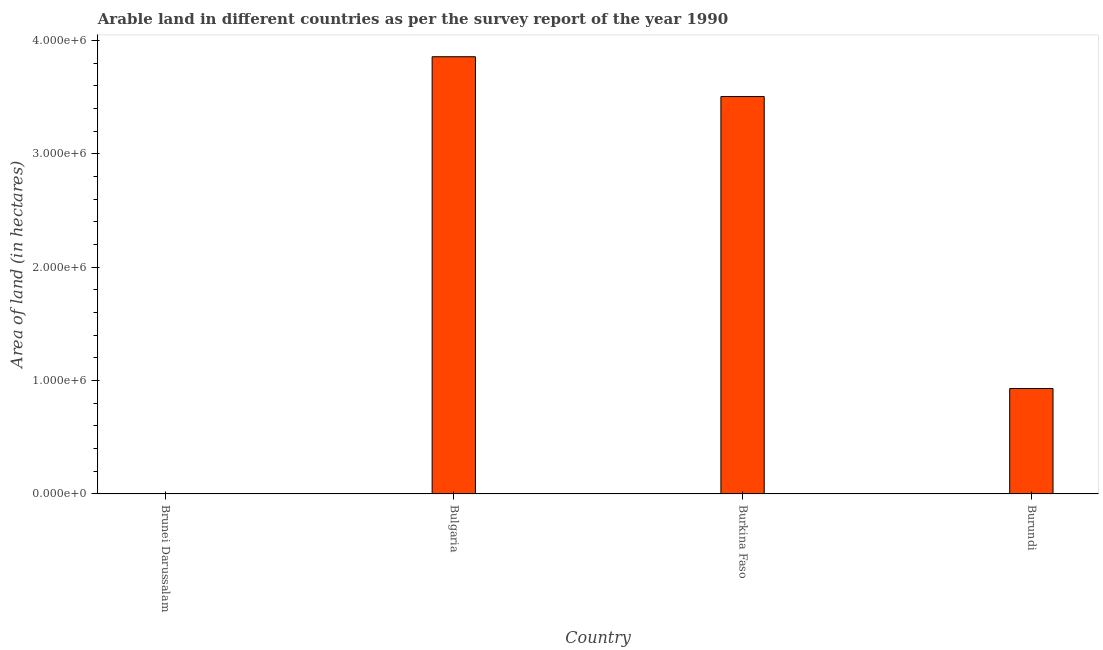Does the graph contain any zero values?
Your answer should be compact. No. What is the title of the graph?
Give a very brief answer. Arable land in different countries as per the survey report of the year 1990. What is the label or title of the Y-axis?
Provide a succinct answer. Area of land (in hectares). What is the area of land in Bulgaria?
Your answer should be very brief. 3.86e+06. Across all countries, what is the maximum area of land?
Make the answer very short. 3.86e+06. Across all countries, what is the minimum area of land?
Provide a succinct answer. 2000. In which country was the area of land maximum?
Keep it short and to the point. Bulgaria. In which country was the area of land minimum?
Give a very brief answer. Brunei Darussalam. What is the sum of the area of land?
Offer a very short reply. 8.29e+06. What is the difference between the area of land in Brunei Darussalam and Bulgaria?
Give a very brief answer. -3.85e+06. What is the average area of land per country?
Your answer should be very brief. 2.07e+06. What is the median area of land?
Make the answer very short. 2.22e+06. What is the ratio of the area of land in Bulgaria to that in Burkina Faso?
Provide a short and direct response. 1.1. Is the area of land in Bulgaria less than that in Burundi?
Offer a very short reply. No. Is the difference between the area of land in Brunei Darussalam and Bulgaria greater than the difference between any two countries?
Offer a very short reply. Yes. What is the difference between the highest and the second highest area of land?
Your answer should be compact. 3.51e+05. What is the difference between the highest and the lowest area of land?
Make the answer very short. 3.85e+06. In how many countries, is the area of land greater than the average area of land taken over all countries?
Offer a terse response. 2. What is the Area of land (in hectares) in Bulgaria?
Provide a succinct answer. 3.86e+06. What is the Area of land (in hectares) of Burkina Faso?
Provide a succinct answer. 3.50e+06. What is the Area of land (in hectares) of Burundi?
Your response must be concise. 9.30e+05. What is the difference between the Area of land (in hectares) in Brunei Darussalam and Bulgaria?
Your answer should be compact. -3.85e+06. What is the difference between the Area of land (in hectares) in Brunei Darussalam and Burkina Faso?
Provide a short and direct response. -3.50e+06. What is the difference between the Area of land (in hectares) in Brunei Darussalam and Burundi?
Make the answer very short. -9.28e+05. What is the difference between the Area of land (in hectares) in Bulgaria and Burkina Faso?
Your response must be concise. 3.51e+05. What is the difference between the Area of land (in hectares) in Bulgaria and Burundi?
Offer a terse response. 2.93e+06. What is the difference between the Area of land (in hectares) in Burkina Faso and Burundi?
Your answer should be very brief. 2.58e+06. What is the ratio of the Area of land (in hectares) in Brunei Darussalam to that in Bulgaria?
Provide a succinct answer. 0. What is the ratio of the Area of land (in hectares) in Brunei Darussalam to that in Burkina Faso?
Give a very brief answer. 0. What is the ratio of the Area of land (in hectares) in Brunei Darussalam to that in Burundi?
Provide a succinct answer. 0. What is the ratio of the Area of land (in hectares) in Bulgaria to that in Burkina Faso?
Offer a terse response. 1.1. What is the ratio of the Area of land (in hectares) in Bulgaria to that in Burundi?
Provide a succinct answer. 4.15. What is the ratio of the Area of land (in hectares) in Burkina Faso to that in Burundi?
Provide a short and direct response. 3.77. 